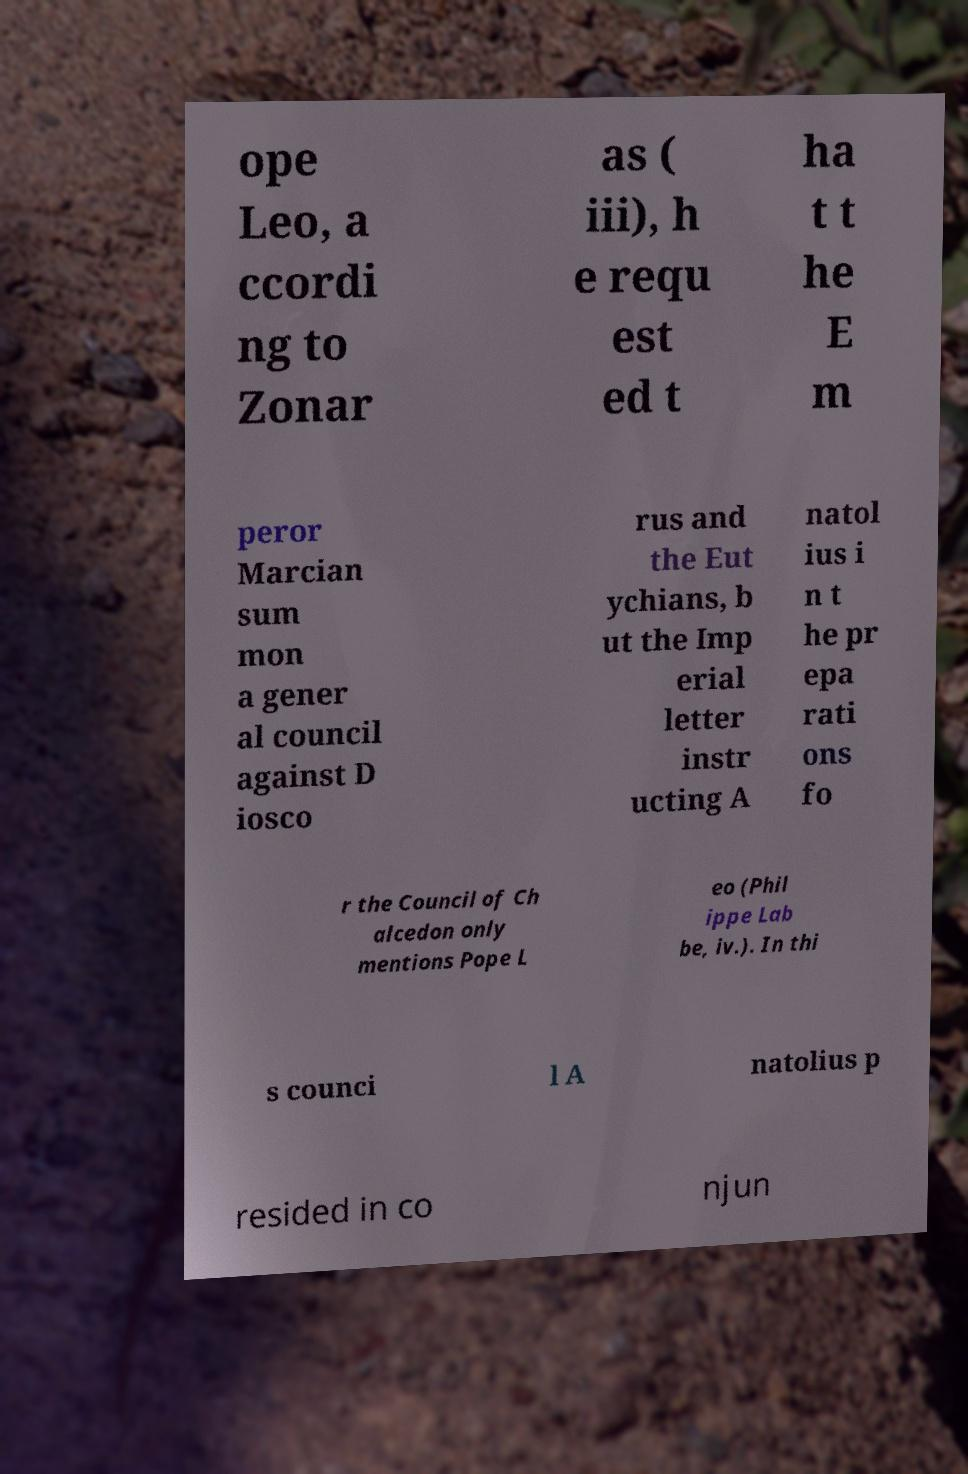Can you accurately transcribe the text from the provided image for me? ope Leo, a ccordi ng to Zonar as ( iii), h e requ est ed t ha t t he E m peror Marcian sum mon a gener al council against D iosco rus and the Eut ychians, b ut the Imp erial letter instr ucting A natol ius i n t he pr epa rati ons fo r the Council of Ch alcedon only mentions Pope L eo (Phil ippe Lab be, iv.). In thi s counci l A natolius p resided in co njun 